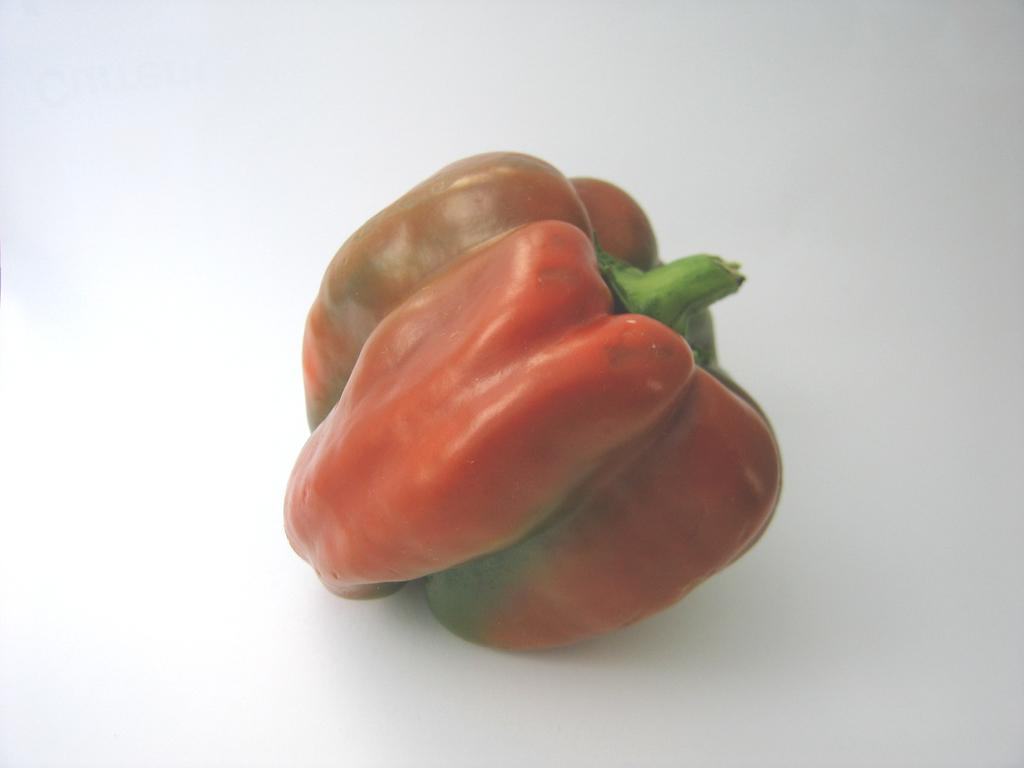What type of vegetable is present in the image? There is a red color capsicum in the image. How many trucks are parked in the room in the image? There is no room or trucks present in the image; it features a red color capsicum. 